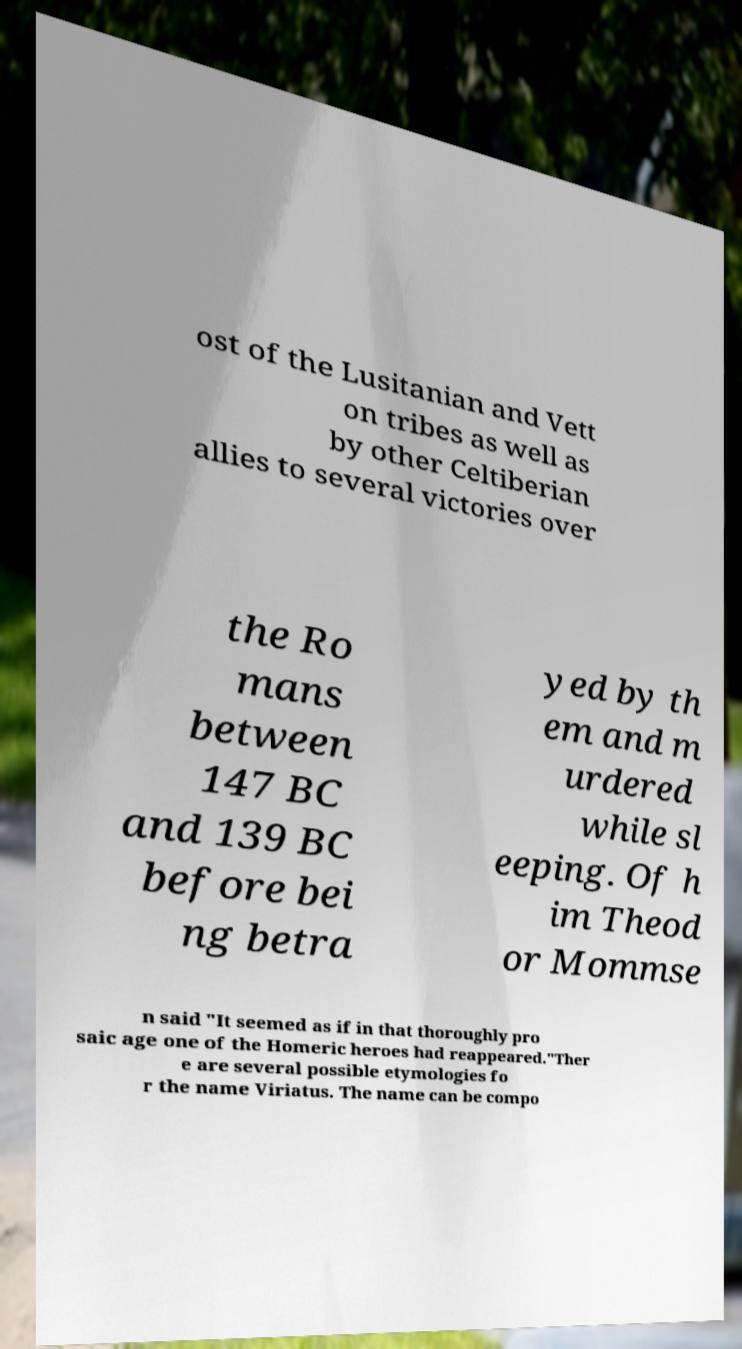Can you accurately transcribe the text from the provided image for me? ost of the Lusitanian and Vett on tribes as well as by other Celtiberian allies to several victories over the Ro mans between 147 BC and 139 BC before bei ng betra yed by th em and m urdered while sl eeping. Of h im Theod or Mommse n said "It seemed as if in that thoroughly pro saic age one of the Homeric heroes had reappeared."Ther e are several possible etymologies fo r the name Viriatus. The name can be compo 